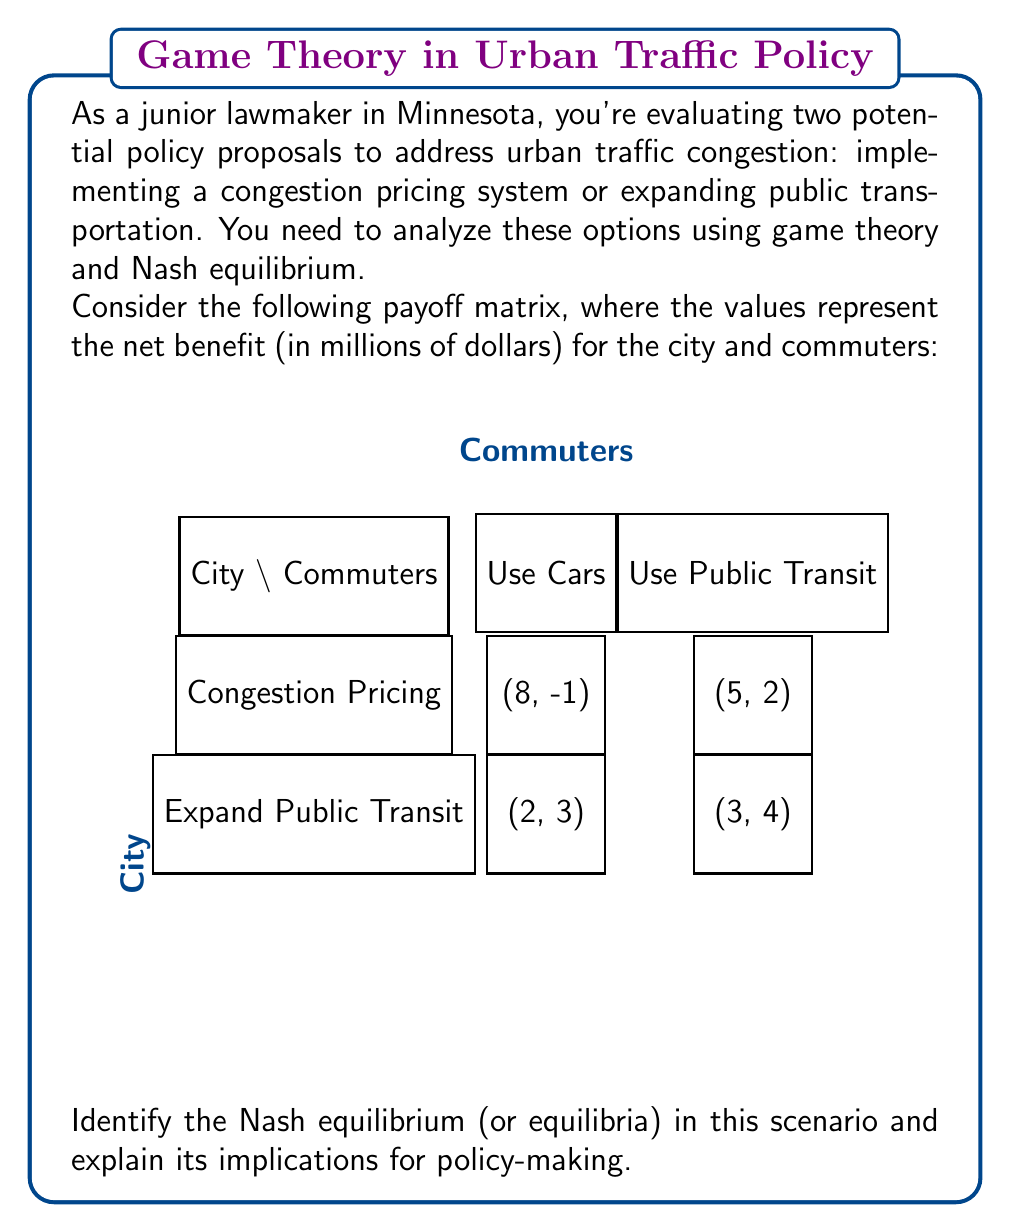Help me with this question. To find the Nash equilibrium, we need to analyze each player's best response to the other player's strategies.

Step 1: Analyze the City's strategies
- If commuters use cars:
  Congestion Pricing payoff: 8
  Expand Public Transit payoff: 2
  Best response: Congestion Pricing
- If commuters use public transit:
  Congestion Pricing payoff: 5
  Expand Public Transit payoff: 3
  Best response: Congestion Pricing

Step 2: Analyze the Commuters' strategies
- If city chooses Congestion Pricing:
  Use Cars payoff: -1
  Use Public Transit payoff: 2
  Best response: Use Public Transit
- If city chooses Expand Public Transit:
  Use Cars payoff: 4
  Use Public Transit payoff: 3
  Best response: Use Cars

Step 3: Identify Nash equilibrium
The Nash equilibrium occurs where both players are playing their best response to the other's strategy. In this case, there is one Nash equilibrium:

(Congestion Pricing, Use Public Transit) with payoffs (5, 2)

Step 4: Interpret the results
This Nash equilibrium suggests that:
1. The city's optimal strategy is to implement congestion pricing.
2. Commuters' optimal response is to shift to public transit.
3. This outcome results in a net benefit of $5 million for the city and $2 million for commuters.

Implications for policy-making:
1. Implementing congestion pricing is likely to be more effective than expanding public transit.
2. The policy will encourage a shift towards public transit use.
3. Both the city and commuters benefit, although the city gains more.
4. This outcome aligns with the goal of reducing urban traffic congestion.

However, it's important to note that while this is the equilibrium, it may not be the most socially optimal outcome. The (Expand Public Transit, Use Public Transit) strategy has a higher combined payoff (3 + 3 = 6) compared to the equilibrium (5 + 2 = 7), but it's not stable as players have incentives to deviate from it.
Answer: Nash equilibrium: (Congestion Pricing, Use Public Transit) 